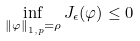Convert formula to latex. <formula><loc_0><loc_0><loc_500><loc_500>\inf _ { \left \| \varphi \right \| _ { 1 , p } = \rho } J _ { \epsilon } ( \varphi ) \leq 0</formula> 